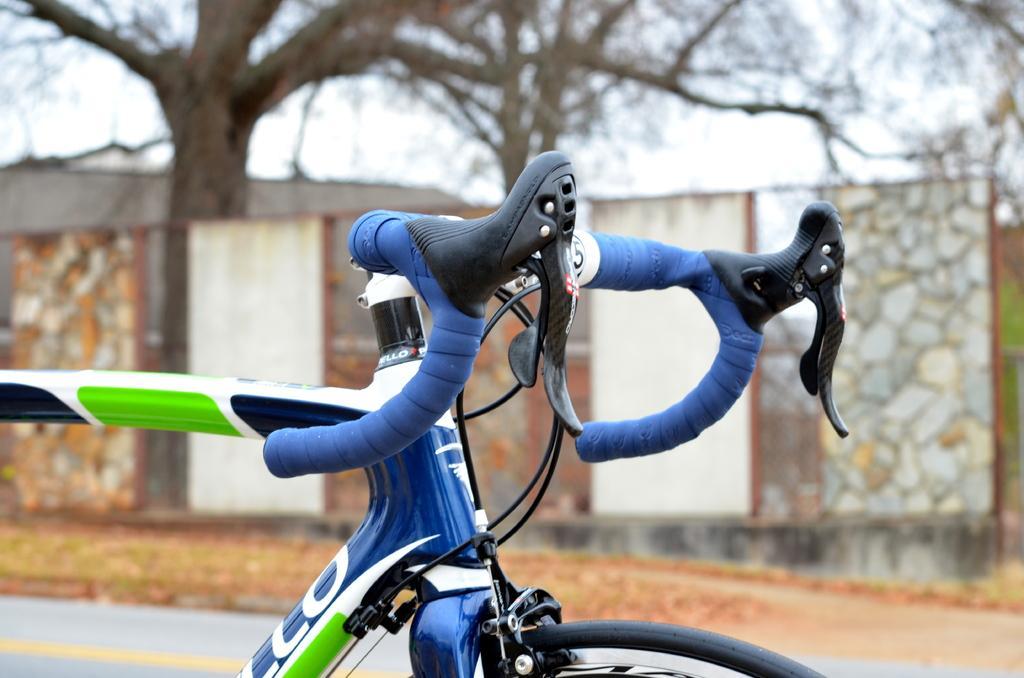Describe this image in one or two sentences. In this image there is a bicycle. In the background there is a wall, tree and a sky. 